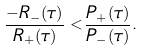<formula> <loc_0><loc_0><loc_500><loc_500>\frac { - R _ { - } ( \tau ) } { R _ { + } ( \tau ) } < \frac { P _ { + } ( \tau ) } { P _ { - } ( \tau ) } .</formula> 